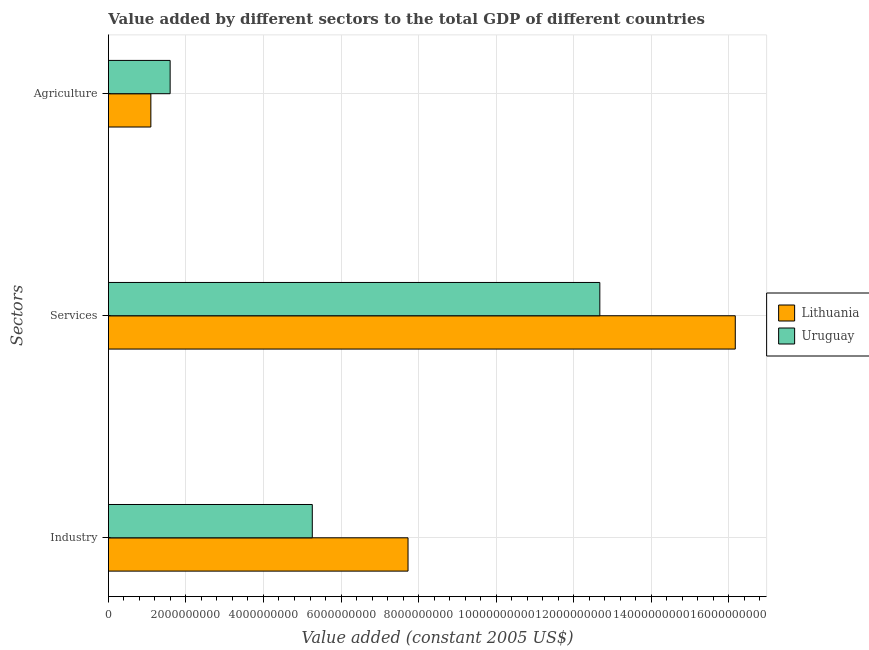How many different coloured bars are there?
Ensure brevity in your answer.  2. How many groups of bars are there?
Your answer should be compact. 3. Are the number of bars per tick equal to the number of legend labels?
Your answer should be very brief. Yes. What is the label of the 3rd group of bars from the top?
Your answer should be very brief. Industry. What is the value added by industrial sector in Uruguay?
Keep it short and to the point. 5.26e+09. Across all countries, what is the maximum value added by agricultural sector?
Your response must be concise. 1.59e+09. Across all countries, what is the minimum value added by services?
Your response must be concise. 1.27e+1. In which country was the value added by industrial sector maximum?
Provide a succinct answer. Lithuania. In which country was the value added by services minimum?
Your response must be concise. Uruguay. What is the total value added by services in the graph?
Provide a short and direct response. 2.88e+1. What is the difference between the value added by agricultural sector in Lithuania and that in Uruguay?
Provide a succinct answer. -4.97e+08. What is the difference between the value added by agricultural sector in Uruguay and the value added by services in Lithuania?
Provide a short and direct response. -1.46e+1. What is the average value added by industrial sector per country?
Make the answer very short. 6.49e+09. What is the difference between the value added by industrial sector and value added by services in Uruguay?
Give a very brief answer. -7.42e+09. In how many countries, is the value added by industrial sector greater than 10000000000 US$?
Make the answer very short. 0. What is the ratio of the value added by industrial sector in Lithuania to that in Uruguay?
Your answer should be compact. 1.47. Is the value added by agricultural sector in Uruguay less than that in Lithuania?
Your response must be concise. No. Is the difference between the value added by industrial sector in Uruguay and Lithuania greater than the difference between the value added by agricultural sector in Uruguay and Lithuania?
Give a very brief answer. No. What is the difference between the highest and the second highest value added by agricultural sector?
Your answer should be very brief. 4.97e+08. What is the difference between the highest and the lowest value added by services?
Provide a short and direct response. 3.49e+09. In how many countries, is the value added by agricultural sector greater than the average value added by agricultural sector taken over all countries?
Offer a terse response. 1. What does the 1st bar from the top in Services represents?
Your answer should be very brief. Uruguay. What does the 2nd bar from the bottom in Services represents?
Your response must be concise. Uruguay. How many countries are there in the graph?
Make the answer very short. 2. What is the difference between two consecutive major ticks on the X-axis?
Ensure brevity in your answer.  2.00e+09. Does the graph contain any zero values?
Provide a short and direct response. No. Does the graph contain grids?
Ensure brevity in your answer.  Yes. How many legend labels are there?
Provide a succinct answer. 2. What is the title of the graph?
Offer a very short reply. Value added by different sectors to the total GDP of different countries. Does "Grenada" appear as one of the legend labels in the graph?
Your answer should be very brief. No. What is the label or title of the X-axis?
Offer a very short reply. Value added (constant 2005 US$). What is the label or title of the Y-axis?
Your answer should be compact. Sectors. What is the Value added (constant 2005 US$) in Lithuania in Industry?
Offer a terse response. 7.73e+09. What is the Value added (constant 2005 US$) in Uruguay in Industry?
Provide a succinct answer. 5.26e+09. What is the Value added (constant 2005 US$) in Lithuania in Services?
Keep it short and to the point. 1.62e+1. What is the Value added (constant 2005 US$) of Uruguay in Services?
Offer a very short reply. 1.27e+1. What is the Value added (constant 2005 US$) in Lithuania in Agriculture?
Keep it short and to the point. 1.09e+09. What is the Value added (constant 2005 US$) of Uruguay in Agriculture?
Give a very brief answer. 1.59e+09. Across all Sectors, what is the maximum Value added (constant 2005 US$) in Lithuania?
Your response must be concise. 1.62e+1. Across all Sectors, what is the maximum Value added (constant 2005 US$) in Uruguay?
Ensure brevity in your answer.  1.27e+1. Across all Sectors, what is the minimum Value added (constant 2005 US$) in Lithuania?
Offer a terse response. 1.09e+09. Across all Sectors, what is the minimum Value added (constant 2005 US$) of Uruguay?
Offer a very short reply. 1.59e+09. What is the total Value added (constant 2005 US$) of Lithuania in the graph?
Offer a very short reply. 2.50e+1. What is the total Value added (constant 2005 US$) of Uruguay in the graph?
Your response must be concise. 1.95e+1. What is the difference between the Value added (constant 2005 US$) of Lithuania in Industry and that in Services?
Offer a very short reply. -8.44e+09. What is the difference between the Value added (constant 2005 US$) in Uruguay in Industry and that in Services?
Make the answer very short. -7.42e+09. What is the difference between the Value added (constant 2005 US$) of Lithuania in Industry and that in Agriculture?
Offer a terse response. 6.63e+09. What is the difference between the Value added (constant 2005 US$) of Uruguay in Industry and that in Agriculture?
Your response must be concise. 3.67e+09. What is the difference between the Value added (constant 2005 US$) of Lithuania in Services and that in Agriculture?
Make the answer very short. 1.51e+1. What is the difference between the Value added (constant 2005 US$) in Uruguay in Services and that in Agriculture?
Your answer should be compact. 1.11e+1. What is the difference between the Value added (constant 2005 US$) of Lithuania in Industry and the Value added (constant 2005 US$) of Uruguay in Services?
Your answer should be compact. -4.95e+09. What is the difference between the Value added (constant 2005 US$) in Lithuania in Industry and the Value added (constant 2005 US$) in Uruguay in Agriculture?
Keep it short and to the point. 6.14e+09. What is the difference between the Value added (constant 2005 US$) of Lithuania in Services and the Value added (constant 2005 US$) of Uruguay in Agriculture?
Keep it short and to the point. 1.46e+1. What is the average Value added (constant 2005 US$) of Lithuania per Sectors?
Your answer should be compact. 8.33e+09. What is the average Value added (constant 2005 US$) in Uruguay per Sectors?
Keep it short and to the point. 6.51e+09. What is the difference between the Value added (constant 2005 US$) in Lithuania and Value added (constant 2005 US$) in Uruguay in Industry?
Give a very brief answer. 2.47e+09. What is the difference between the Value added (constant 2005 US$) of Lithuania and Value added (constant 2005 US$) of Uruguay in Services?
Provide a succinct answer. 3.49e+09. What is the difference between the Value added (constant 2005 US$) in Lithuania and Value added (constant 2005 US$) in Uruguay in Agriculture?
Provide a short and direct response. -4.97e+08. What is the ratio of the Value added (constant 2005 US$) of Lithuania in Industry to that in Services?
Your response must be concise. 0.48. What is the ratio of the Value added (constant 2005 US$) in Uruguay in Industry to that in Services?
Your answer should be very brief. 0.41. What is the ratio of the Value added (constant 2005 US$) of Lithuania in Industry to that in Agriculture?
Ensure brevity in your answer.  7.06. What is the ratio of the Value added (constant 2005 US$) in Uruguay in Industry to that in Agriculture?
Offer a very short reply. 3.3. What is the ratio of the Value added (constant 2005 US$) of Lithuania in Services to that in Agriculture?
Provide a short and direct response. 14.77. What is the ratio of the Value added (constant 2005 US$) in Uruguay in Services to that in Agriculture?
Your answer should be very brief. 7.96. What is the difference between the highest and the second highest Value added (constant 2005 US$) in Lithuania?
Offer a terse response. 8.44e+09. What is the difference between the highest and the second highest Value added (constant 2005 US$) in Uruguay?
Make the answer very short. 7.42e+09. What is the difference between the highest and the lowest Value added (constant 2005 US$) of Lithuania?
Make the answer very short. 1.51e+1. What is the difference between the highest and the lowest Value added (constant 2005 US$) in Uruguay?
Ensure brevity in your answer.  1.11e+1. 